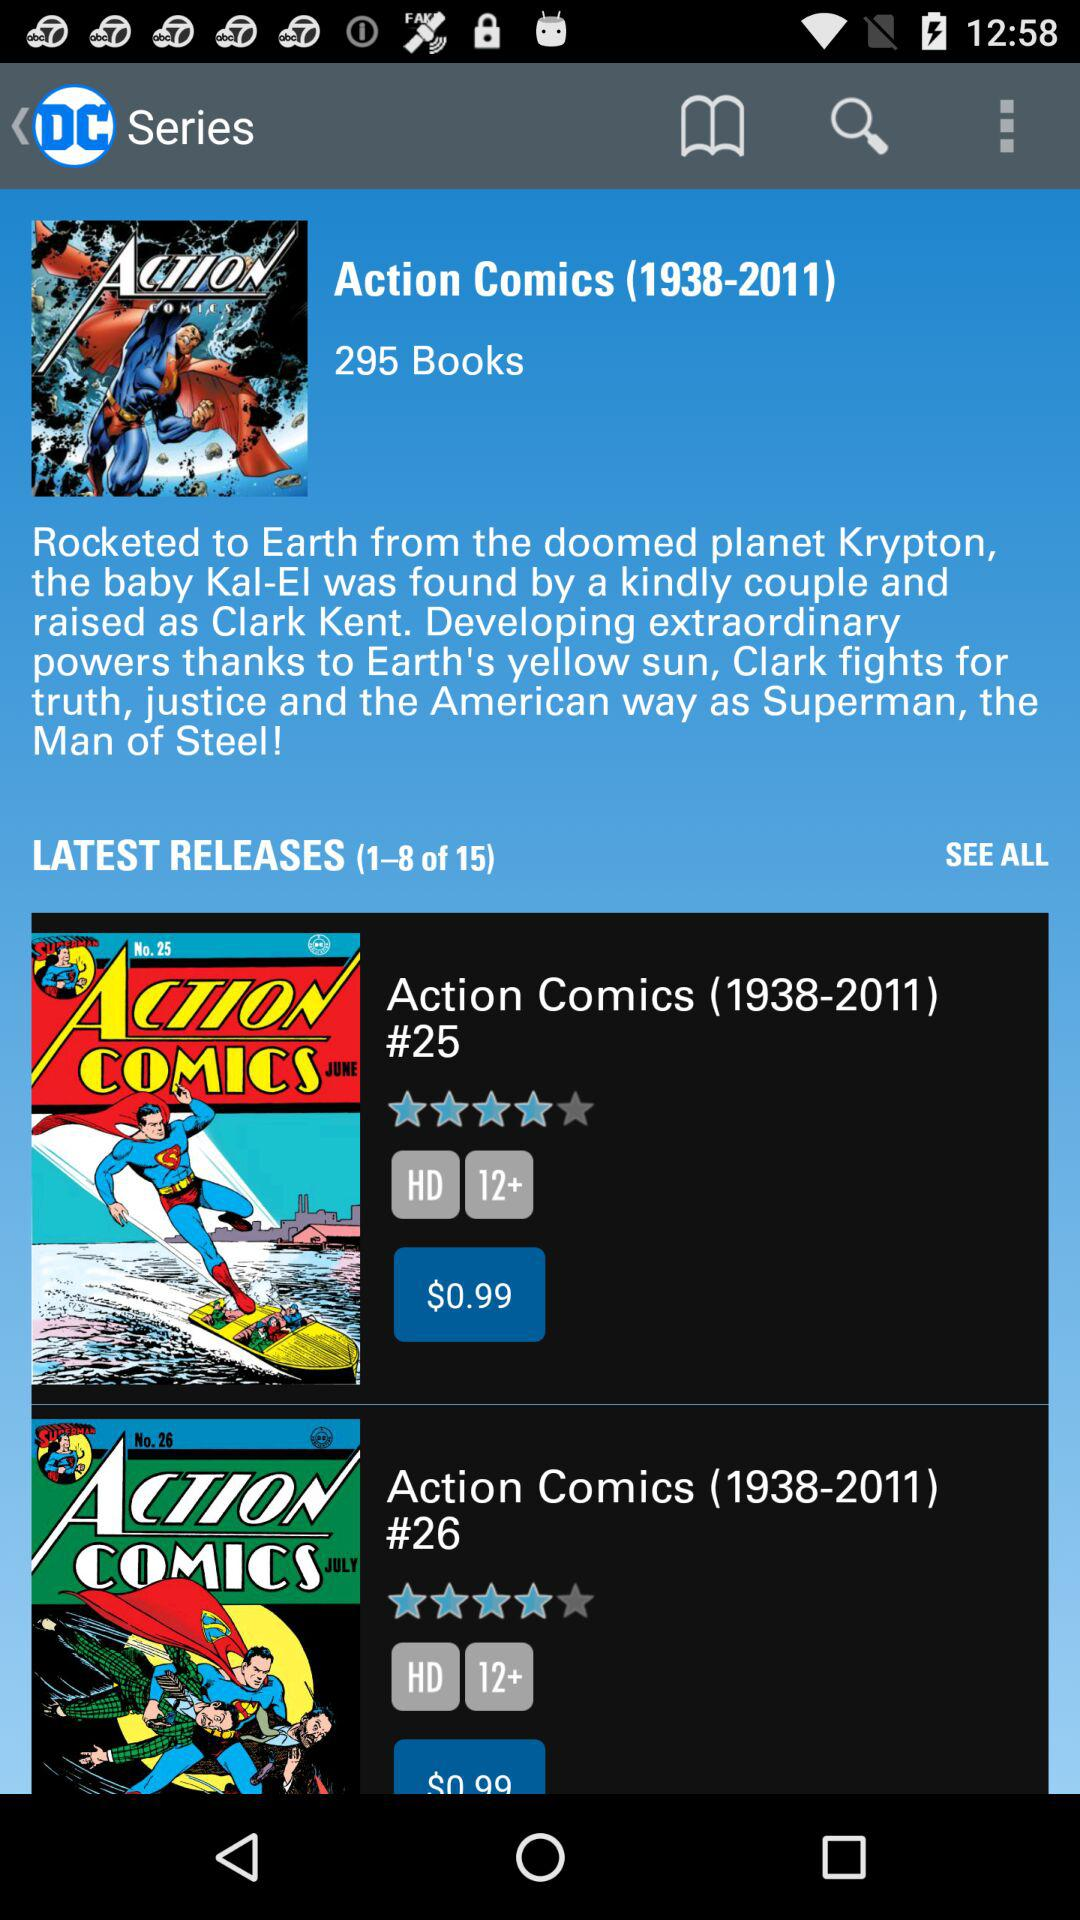What is the age restriction for "Action Comics (1938-2011) #25" books? The age restriction for "Action Comics (1938-2011) #25" books is more than 12 years. 